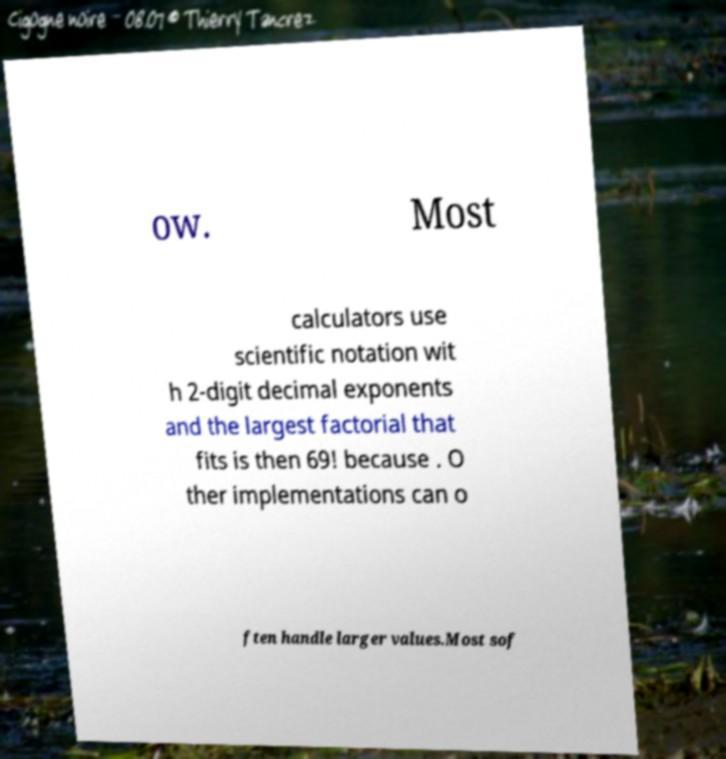Can you accurately transcribe the text from the provided image for me? ow. Most calculators use scientific notation wit h 2-digit decimal exponents and the largest factorial that fits is then 69! because . O ther implementations can o ften handle larger values.Most sof 